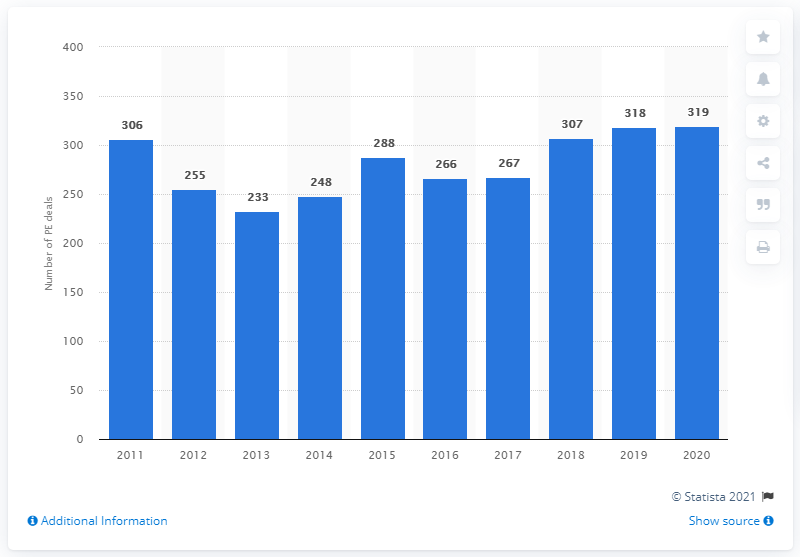Specify some key components in this picture. In 2020, the total volume of PE (Private Equity) transactions was 319. 